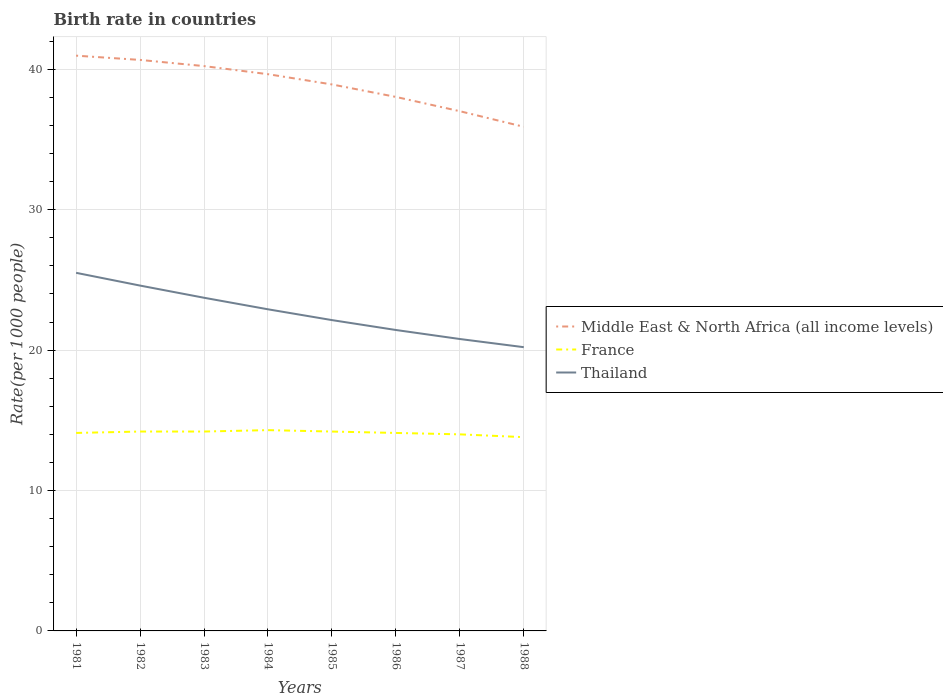How many different coloured lines are there?
Offer a very short reply. 3. Is the number of lines equal to the number of legend labels?
Provide a succinct answer. Yes. Across all years, what is the maximum birth rate in Middle East & North Africa (all income levels)?
Offer a very short reply. 35.9. In which year was the birth rate in Middle East & North Africa (all income levels) maximum?
Give a very brief answer. 1988. What is the total birth rate in Thailand in the graph?
Provide a short and direct response. 3.52. What is the difference between the highest and the second highest birth rate in Thailand?
Offer a terse response. 5.3. How many lines are there?
Your response must be concise. 3. What is the title of the graph?
Your response must be concise. Birth rate in countries. Does "China" appear as one of the legend labels in the graph?
Give a very brief answer. No. What is the label or title of the X-axis?
Your answer should be compact. Years. What is the label or title of the Y-axis?
Ensure brevity in your answer.  Rate(per 1000 people). What is the Rate(per 1000 people) in Middle East & North Africa (all income levels) in 1981?
Give a very brief answer. 40.97. What is the Rate(per 1000 people) in France in 1981?
Your response must be concise. 14.1. What is the Rate(per 1000 people) in Thailand in 1981?
Give a very brief answer. 25.5. What is the Rate(per 1000 people) in Middle East & North Africa (all income levels) in 1982?
Your answer should be compact. 40.67. What is the Rate(per 1000 people) of Thailand in 1982?
Your response must be concise. 24.59. What is the Rate(per 1000 people) of Middle East & North Africa (all income levels) in 1983?
Your answer should be very brief. 40.23. What is the Rate(per 1000 people) of France in 1983?
Your answer should be compact. 14.2. What is the Rate(per 1000 people) in Thailand in 1983?
Give a very brief answer. 23.73. What is the Rate(per 1000 people) of Middle East & North Africa (all income levels) in 1984?
Offer a very short reply. 39.65. What is the Rate(per 1000 people) in France in 1984?
Provide a succinct answer. 14.3. What is the Rate(per 1000 people) of Thailand in 1984?
Your answer should be compact. 22.91. What is the Rate(per 1000 people) of Middle East & North Africa (all income levels) in 1985?
Give a very brief answer. 38.92. What is the Rate(per 1000 people) in Thailand in 1985?
Provide a succinct answer. 22.14. What is the Rate(per 1000 people) in Middle East & North Africa (all income levels) in 1986?
Your answer should be compact. 38.03. What is the Rate(per 1000 people) in France in 1986?
Your answer should be compact. 14.1. What is the Rate(per 1000 people) of Thailand in 1986?
Offer a very short reply. 21.43. What is the Rate(per 1000 people) in Middle East & North Africa (all income levels) in 1987?
Provide a short and direct response. 37.01. What is the Rate(per 1000 people) of France in 1987?
Make the answer very short. 14. What is the Rate(per 1000 people) of Thailand in 1987?
Your response must be concise. 20.79. What is the Rate(per 1000 people) in Middle East & North Africa (all income levels) in 1988?
Provide a short and direct response. 35.9. What is the Rate(per 1000 people) in France in 1988?
Offer a very short reply. 13.8. What is the Rate(per 1000 people) in Thailand in 1988?
Offer a terse response. 20.21. Across all years, what is the maximum Rate(per 1000 people) of Middle East & North Africa (all income levels)?
Your answer should be very brief. 40.97. Across all years, what is the maximum Rate(per 1000 people) of France?
Offer a very short reply. 14.3. Across all years, what is the maximum Rate(per 1000 people) in Thailand?
Your answer should be very brief. 25.5. Across all years, what is the minimum Rate(per 1000 people) in Middle East & North Africa (all income levels)?
Give a very brief answer. 35.9. Across all years, what is the minimum Rate(per 1000 people) in Thailand?
Keep it short and to the point. 20.21. What is the total Rate(per 1000 people) of Middle East & North Africa (all income levels) in the graph?
Make the answer very short. 311.39. What is the total Rate(per 1000 people) in France in the graph?
Keep it short and to the point. 112.9. What is the total Rate(per 1000 people) in Thailand in the graph?
Your response must be concise. 181.3. What is the difference between the Rate(per 1000 people) in Middle East & North Africa (all income levels) in 1981 and that in 1982?
Provide a short and direct response. 0.3. What is the difference between the Rate(per 1000 people) in Thailand in 1981 and that in 1982?
Your answer should be very brief. 0.91. What is the difference between the Rate(per 1000 people) in Middle East & North Africa (all income levels) in 1981 and that in 1983?
Provide a succinct answer. 0.74. What is the difference between the Rate(per 1000 people) of France in 1981 and that in 1983?
Your answer should be compact. -0.1. What is the difference between the Rate(per 1000 people) in Thailand in 1981 and that in 1983?
Your answer should be very brief. 1.78. What is the difference between the Rate(per 1000 people) in Middle East & North Africa (all income levels) in 1981 and that in 1984?
Keep it short and to the point. 1.32. What is the difference between the Rate(per 1000 people) of Thailand in 1981 and that in 1984?
Offer a very short reply. 2.6. What is the difference between the Rate(per 1000 people) of Middle East & North Africa (all income levels) in 1981 and that in 1985?
Your answer should be very brief. 2.05. What is the difference between the Rate(per 1000 people) in Thailand in 1981 and that in 1985?
Your response must be concise. 3.37. What is the difference between the Rate(per 1000 people) of Middle East & North Africa (all income levels) in 1981 and that in 1986?
Provide a short and direct response. 2.94. What is the difference between the Rate(per 1000 people) in France in 1981 and that in 1986?
Offer a very short reply. 0. What is the difference between the Rate(per 1000 people) of Thailand in 1981 and that in 1986?
Offer a terse response. 4.07. What is the difference between the Rate(per 1000 people) of Middle East & North Africa (all income levels) in 1981 and that in 1987?
Provide a short and direct response. 3.96. What is the difference between the Rate(per 1000 people) of Thailand in 1981 and that in 1987?
Your answer should be compact. 4.71. What is the difference between the Rate(per 1000 people) of Middle East & North Africa (all income levels) in 1981 and that in 1988?
Give a very brief answer. 5.07. What is the difference between the Rate(per 1000 people) in France in 1981 and that in 1988?
Make the answer very short. 0.3. What is the difference between the Rate(per 1000 people) of Thailand in 1981 and that in 1988?
Ensure brevity in your answer.  5.3. What is the difference between the Rate(per 1000 people) of Middle East & North Africa (all income levels) in 1982 and that in 1983?
Provide a succinct answer. 0.44. What is the difference between the Rate(per 1000 people) of France in 1982 and that in 1983?
Your response must be concise. 0. What is the difference between the Rate(per 1000 people) in Thailand in 1982 and that in 1983?
Your answer should be very brief. 0.87. What is the difference between the Rate(per 1000 people) in Middle East & North Africa (all income levels) in 1982 and that in 1984?
Make the answer very short. 1.02. What is the difference between the Rate(per 1000 people) in Thailand in 1982 and that in 1984?
Offer a terse response. 1.69. What is the difference between the Rate(per 1000 people) in Middle East & North Africa (all income levels) in 1982 and that in 1985?
Your response must be concise. 1.75. What is the difference between the Rate(per 1000 people) in Thailand in 1982 and that in 1985?
Keep it short and to the point. 2.46. What is the difference between the Rate(per 1000 people) in Middle East & North Africa (all income levels) in 1982 and that in 1986?
Your answer should be compact. 2.63. What is the difference between the Rate(per 1000 people) in France in 1982 and that in 1986?
Offer a terse response. 0.1. What is the difference between the Rate(per 1000 people) of Thailand in 1982 and that in 1986?
Your answer should be very brief. 3.16. What is the difference between the Rate(per 1000 people) of Middle East & North Africa (all income levels) in 1982 and that in 1987?
Make the answer very short. 3.65. What is the difference between the Rate(per 1000 people) in Thailand in 1982 and that in 1987?
Make the answer very short. 3.81. What is the difference between the Rate(per 1000 people) of Middle East & North Africa (all income levels) in 1982 and that in 1988?
Keep it short and to the point. 4.76. What is the difference between the Rate(per 1000 people) of France in 1982 and that in 1988?
Offer a terse response. 0.4. What is the difference between the Rate(per 1000 people) of Thailand in 1982 and that in 1988?
Your answer should be very brief. 4.39. What is the difference between the Rate(per 1000 people) of Middle East & North Africa (all income levels) in 1983 and that in 1984?
Your answer should be compact. 0.58. What is the difference between the Rate(per 1000 people) in Thailand in 1983 and that in 1984?
Your response must be concise. 0.82. What is the difference between the Rate(per 1000 people) in Middle East & North Africa (all income levels) in 1983 and that in 1985?
Your answer should be compact. 1.31. What is the difference between the Rate(per 1000 people) in France in 1983 and that in 1985?
Offer a terse response. 0. What is the difference between the Rate(per 1000 people) in Thailand in 1983 and that in 1985?
Keep it short and to the point. 1.59. What is the difference between the Rate(per 1000 people) in Middle East & North Africa (all income levels) in 1983 and that in 1986?
Your answer should be very brief. 2.2. What is the difference between the Rate(per 1000 people) in Thailand in 1983 and that in 1986?
Give a very brief answer. 2.3. What is the difference between the Rate(per 1000 people) of Middle East & North Africa (all income levels) in 1983 and that in 1987?
Give a very brief answer. 3.21. What is the difference between the Rate(per 1000 people) in Thailand in 1983 and that in 1987?
Your response must be concise. 2.94. What is the difference between the Rate(per 1000 people) of Middle East & North Africa (all income levels) in 1983 and that in 1988?
Provide a succinct answer. 4.32. What is the difference between the Rate(per 1000 people) in France in 1983 and that in 1988?
Offer a very short reply. 0.4. What is the difference between the Rate(per 1000 people) of Thailand in 1983 and that in 1988?
Offer a very short reply. 3.52. What is the difference between the Rate(per 1000 people) of Middle East & North Africa (all income levels) in 1984 and that in 1985?
Your response must be concise. 0.73. What is the difference between the Rate(per 1000 people) in France in 1984 and that in 1985?
Ensure brevity in your answer.  0.1. What is the difference between the Rate(per 1000 people) in Thailand in 1984 and that in 1985?
Offer a very short reply. 0.77. What is the difference between the Rate(per 1000 people) in Middle East & North Africa (all income levels) in 1984 and that in 1986?
Ensure brevity in your answer.  1.62. What is the difference between the Rate(per 1000 people) of Thailand in 1984 and that in 1986?
Offer a terse response. 1.47. What is the difference between the Rate(per 1000 people) in Middle East & North Africa (all income levels) in 1984 and that in 1987?
Offer a terse response. 2.64. What is the difference between the Rate(per 1000 people) of Thailand in 1984 and that in 1987?
Offer a very short reply. 2.12. What is the difference between the Rate(per 1000 people) of Middle East & North Africa (all income levels) in 1984 and that in 1988?
Offer a terse response. 3.75. What is the difference between the Rate(per 1000 people) in Thailand in 1984 and that in 1988?
Provide a succinct answer. 2.7. What is the difference between the Rate(per 1000 people) of Middle East & North Africa (all income levels) in 1985 and that in 1986?
Your answer should be compact. 0.89. What is the difference between the Rate(per 1000 people) in France in 1985 and that in 1986?
Give a very brief answer. 0.1. What is the difference between the Rate(per 1000 people) in Thailand in 1985 and that in 1986?
Your response must be concise. 0.7. What is the difference between the Rate(per 1000 people) of Middle East & North Africa (all income levels) in 1985 and that in 1987?
Your answer should be very brief. 1.91. What is the difference between the Rate(per 1000 people) in France in 1985 and that in 1987?
Your answer should be compact. 0.2. What is the difference between the Rate(per 1000 people) in Thailand in 1985 and that in 1987?
Give a very brief answer. 1.35. What is the difference between the Rate(per 1000 people) of Middle East & North Africa (all income levels) in 1985 and that in 1988?
Your response must be concise. 3.02. What is the difference between the Rate(per 1000 people) in Thailand in 1985 and that in 1988?
Offer a very short reply. 1.93. What is the difference between the Rate(per 1000 people) in Middle East & North Africa (all income levels) in 1986 and that in 1987?
Your response must be concise. 1.02. What is the difference between the Rate(per 1000 people) of Thailand in 1986 and that in 1987?
Your response must be concise. 0.64. What is the difference between the Rate(per 1000 people) in Middle East & North Africa (all income levels) in 1986 and that in 1988?
Ensure brevity in your answer.  2.13. What is the difference between the Rate(per 1000 people) in Thailand in 1986 and that in 1988?
Provide a short and direct response. 1.22. What is the difference between the Rate(per 1000 people) of Middle East & North Africa (all income levels) in 1987 and that in 1988?
Make the answer very short. 1.11. What is the difference between the Rate(per 1000 people) of Thailand in 1987 and that in 1988?
Ensure brevity in your answer.  0.58. What is the difference between the Rate(per 1000 people) of Middle East & North Africa (all income levels) in 1981 and the Rate(per 1000 people) of France in 1982?
Your answer should be compact. 26.77. What is the difference between the Rate(per 1000 people) in Middle East & North Africa (all income levels) in 1981 and the Rate(per 1000 people) in Thailand in 1982?
Keep it short and to the point. 16.38. What is the difference between the Rate(per 1000 people) in France in 1981 and the Rate(per 1000 people) in Thailand in 1982?
Your answer should be very brief. -10.49. What is the difference between the Rate(per 1000 people) in Middle East & North Africa (all income levels) in 1981 and the Rate(per 1000 people) in France in 1983?
Your answer should be compact. 26.77. What is the difference between the Rate(per 1000 people) of Middle East & North Africa (all income levels) in 1981 and the Rate(per 1000 people) of Thailand in 1983?
Give a very brief answer. 17.24. What is the difference between the Rate(per 1000 people) of France in 1981 and the Rate(per 1000 people) of Thailand in 1983?
Keep it short and to the point. -9.63. What is the difference between the Rate(per 1000 people) of Middle East & North Africa (all income levels) in 1981 and the Rate(per 1000 people) of France in 1984?
Your response must be concise. 26.67. What is the difference between the Rate(per 1000 people) in Middle East & North Africa (all income levels) in 1981 and the Rate(per 1000 people) in Thailand in 1984?
Your answer should be very brief. 18.06. What is the difference between the Rate(per 1000 people) of France in 1981 and the Rate(per 1000 people) of Thailand in 1984?
Ensure brevity in your answer.  -8.81. What is the difference between the Rate(per 1000 people) of Middle East & North Africa (all income levels) in 1981 and the Rate(per 1000 people) of France in 1985?
Your response must be concise. 26.77. What is the difference between the Rate(per 1000 people) of Middle East & North Africa (all income levels) in 1981 and the Rate(per 1000 people) of Thailand in 1985?
Keep it short and to the point. 18.83. What is the difference between the Rate(per 1000 people) in France in 1981 and the Rate(per 1000 people) in Thailand in 1985?
Provide a succinct answer. -8.04. What is the difference between the Rate(per 1000 people) of Middle East & North Africa (all income levels) in 1981 and the Rate(per 1000 people) of France in 1986?
Your answer should be compact. 26.87. What is the difference between the Rate(per 1000 people) in Middle East & North Africa (all income levels) in 1981 and the Rate(per 1000 people) in Thailand in 1986?
Provide a succinct answer. 19.54. What is the difference between the Rate(per 1000 people) of France in 1981 and the Rate(per 1000 people) of Thailand in 1986?
Keep it short and to the point. -7.33. What is the difference between the Rate(per 1000 people) in Middle East & North Africa (all income levels) in 1981 and the Rate(per 1000 people) in France in 1987?
Keep it short and to the point. 26.97. What is the difference between the Rate(per 1000 people) in Middle East & North Africa (all income levels) in 1981 and the Rate(per 1000 people) in Thailand in 1987?
Offer a very short reply. 20.18. What is the difference between the Rate(per 1000 people) of France in 1981 and the Rate(per 1000 people) of Thailand in 1987?
Provide a short and direct response. -6.69. What is the difference between the Rate(per 1000 people) of Middle East & North Africa (all income levels) in 1981 and the Rate(per 1000 people) of France in 1988?
Offer a very short reply. 27.17. What is the difference between the Rate(per 1000 people) in Middle East & North Africa (all income levels) in 1981 and the Rate(per 1000 people) in Thailand in 1988?
Offer a terse response. 20.76. What is the difference between the Rate(per 1000 people) in France in 1981 and the Rate(per 1000 people) in Thailand in 1988?
Ensure brevity in your answer.  -6.11. What is the difference between the Rate(per 1000 people) of Middle East & North Africa (all income levels) in 1982 and the Rate(per 1000 people) of France in 1983?
Your answer should be very brief. 26.47. What is the difference between the Rate(per 1000 people) of Middle East & North Africa (all income levels) in 1982 and the Rate(per 1000 people) of Thailand in 1983?
Offer a terse response. 16.94. What is the difference between the Rate(per 1000 people) of France in 1982 and the Rate(per 1000 people) of Thailand in 1983?
Make the answer very short. -9.53. What is the difference between the Rate(per 1000 people) of Middle East & North Africa (all income levels) in 1982 and the Rate(per 1000 people) of France in 1984?
Offer a very short reply. 26.37. What is the difference between the Rate(per 1000 people) in Middle East & North Africa (all income levels) in 1982 and the Rate(per 1000 people) in Thailand in 1984?
Provide a succinct answer. 17.76. What is the difference between the Rate(per 1000 people) of France in 1982 and the Rate(per 1000 people) of Thailand in 1984?
Give a very brief answer. -8.71. What is the difference between the Rate(per 1000 people) in Middle East & North Africa (all income levels) in 1982 and the Rate(per 1000 people) in France in 1985?
Offer a terse response. 26.47. What is the difference between the Rate(per 1000 people) in Middle East & North Africa (all income levels) in 1982 and the Rate(per 1000 people) in Thailand in 1985?
Provide a short and direct response. 18.53. What is the difference between the Rate(per 1000 people) in France in 1982 and the Rate(per 1000 people) in Thailand in 1985?
Your answer should be very brief. -7.94. What is the difference between the Rate(per 1000 people) of Middle East & North Africa (all income levels) in 1982 and the Rate(per 1000 people) of France in 1986?
Ensure brevity in your answer.  26.57. What is the difference between the Rate(per 1000 people) in Middle East & North Africa (all income levels) in 1982 and the Rate(per 1000 people) in Thailand in 1986?
Give a very brief answer. 19.23. What is the difference between the Rate(per 1000 people) of France in 1982 and the Rate(per 1000 people) of Thailand in 1986?
Give a very brief answer. -7.23. What is the difference between the Rate(per 1000 people) of Middle East & North Africa (all income levels) in 1982 and the Rate(per 1000 people) of France in 1987?
Keep it short and to the point. 26.67. What is the difference between the Rate(per 1000 people) of Middle East & North Africa (all income levels) in 1982 and the Rate(per 1000 people) of Thailand in 1987?
Provide a short and direct response. 19.88. What is the difference between the Rate(per 1000 people) of France in 1982 and the Rate(per 1000 people) of Thailand in 1987?
Ensure brevity in your answer.  -6.59. What is the difference between the Rate(per 1000 people) in Middle East & North Africa (all income levels) in 1982 and the Rate(per 1000 people) in France in 1988?
Give a very brief answer. 26.87. What is the difference between the Rate(per 1000 people) of Middle East & North Africa (all income levels) in 1982 and the Rate(per 1000 people) of Thailand in 1988?
Your answer should be compact. 20.46. What is the difference between the Rate(per 1000 people) of France in 1982 and the Rate(per 1000 people) of Thailand in 1988?
Offer a terse response. -6.01. What is the difference between the Rate(per 1000 people) of Middle East & North Africa (all income levels) in 1983 and the Rate(per 1000 people) of France in 1984?
Provide a short and direct response. 25.93. What is the difference between the Rate(per 1000 people) of Middle East & North Africa (all income levels) in 1983 and the Rate(per 1000 people) of Thailand in 1984?
Offer a terse response. 17.32. What is the difference between the Rate(per 1000 people) in France in 1983 and the Rate(per 1000 people) in Thailand in 1984?
Offer a very short reply. -8.71. What is the difference between the Rate(per 1000 people) in Middle East & North Africa (all income levels) in 1983 and the Rate(per 1000 people) in France in 1985?
Give a very brief answer. 26.03. What is the difference between the Rate(per 1000 people) of Middle East & North Africa (all income levels) in 1983 and the Rate(per 1000 people) of Thailand in 1985?
Your answer should be very brief. 18.09. What is the difference between the Rate(per 1000 people) of France in 1983 and the Rate(per 1000 people) of Thailand in 1985?
Give a very brief answer. -7.94. What is the difference between the Rate(per 1000 people) of Middle East & North Africa (all income levels) in 1983 and the Rate(per 1000 people) of France in 1986?
Your response must be concise. 26.13. What is the difference between the Rate(per 1000 people) in Middle East & North Africa (all income levels) in 1983 and the Rate(per 1000 people) in Thailand in 1986?
Your response must be concise. 18.8. What is the difference between the Rate(per 1000 people) of France in 1983 and the Rate(per 1000 people) of Thailand in 1986?
Make the answer very short. -7.23. What is the difference between the Rate(per 1000 people) in Middle East & North Africa (all income levels) in 1983 and the Rate(per 1000 people) in France in 1987?
Provide a short and direct response. 26.23. What is the difference between the Rate(per 1000 people) of Middle East & North Africa (all income levels) in 1983 and the Rate(per 1000 people) of Thailand in 1987?
Provide a succinct answer. 19.44. What is the difference between the Rate(per 1000 people) in France in 1983 and the Rate(per 1000 people) in Thailand in 1987?
Provide a succinct answer. -6.59. What is the difference between the Rate(per 1000 people) of Middle East & North Africa (all income levels) in 1983 and the Rate(per 1000 people) of France in 1988?
Offer a very short reply. 26.43. What is the difference between the Rate(per 1000 people) in Middle East & North Africa (all income levels) in 1983 and the Rate(per 1000 people) in Thailand in 1988?
Offer a terse response. 20.02. What is the difference between the Rate(per 1000 people) in France in 1983 and the Rate(per 1000 people) in Thailand in 1988?
Your response must be concise. -6.01. What is the difference between the Rate(per 1000 people) of Middle East & North Africa (all income levels) in 1984 and the Rate(per 1000 people) of France in 1985?
Make the answer very short. 25.45. What is the difference between the Rate(per 1000 people) of Middle East & North Africa (all income levels) in 1984 and the Rate(per 1000 people) of Thailand in 1985?
Offer a terse response. 17.51. What is the difference between the Rate(per 1000 people) in France in 1984 and the Rate(per 1000 people) in Thailand in 1985?
Offer a very short reply. -7.84. What is the difference between the Rate(per 1000 people) of Middle East & North Africa (all income levels) in 1984 and the Rate(per 1000 people) of France in 1986?
Offer a terse response. 25.55. What is the difference between the Rate(per 1000 people) of Middle East & North Africa (all income levels) in 1984 and the Rate(per 1000 people) of Thailand in 1986?
Offer a terse response. 18.22. What is the difference between the Rate(per 1000 people) of France in 1984 and the Rate(per 1000 people) of Thailand in 1986?
Keep it short and to the point. -7.13. What is the difference between the Rate(per 1000 people) in Middle East & North Africa (all income levels) in 1984 and the Rate(per 1000 people) in France in 1987?
Provide a succinct answer. 25.65. What is the difference between the Rate(per 1000 people) in Middle East & North Africa (all income levels) in 1984 and the Rate(per 1000 people) in Thailand in 1987?
Keep it short and to the point. 18.86. What is the difference between the Rate(per 1000 people) of France in 1984 and the Rate(per 1000 people) of Thailand in 1987?
Your answer should be very brief. -6.49. What is the difference between the Rate(per 1000 people) of Middle East & North Africa (all income levels) in 1984 and the Rate(per 1000 people) of France in 1988?
Provide a succinct answer. 25.85. What is the difference between the Rate(per 1000 people) of Middle East & North Africa (all income levels) in 1984 and the Rate(per 1000 people) of Thailand in 1988?
Offer a terse response. 19.44. What is the difference between the Rate(per 1000 people) in France in 1984 and the Rate(per 1000 people) in Thailand in 1988?
Give a very brief answer. -5.91. What is the difference between the Rate(per 1000 people) in Middle East & North Africa (all income levels) in 1985 and the Rate(per 1000 people) in France in 1986?
Your answer should be very brief. 24.82. What is the difference between the Rate(per 1000 people) in Middle East & North Africa (all income levels) in 1985 and the Rate(per 1000 people) in Thailand in 1986?
Your answer should be very brief. 17.49. What is the difference between the Rate(per 1000 people) in France in 1985 and the Rate(per 1000 people) in Thailand in 1986?
Provide a short and direct response. -7.23. What is the difference between the Rate(per 1000 people) of Middle East & North Africa (all income levels) in 1985 and the Rate(per 1000 people) of France in 1987?
Provide a succinct answer. 24.92. What is the difference between the Rate(per 1000 people) in Middle East & North Africa (all income levels) in 1985 and the Rate(per 1000 people) in Thailand in 1987?
Ensure brevity in your answer.  18.13. What is the difference between the Rate(per 1000 people) of France in 1985 and the Rate(per 1000 people) of Thailand in 1987?
Your answer should be compact. -6.59. What is the difference between the Rate(per 1000 people) in Middle East & North Africa (all income levels) in 1985 and the Rate(per 1000 people) in France in 1988?
Make the answer very short. 25.12. What is the difference between the Rate(per 1000 people) in Middle East & North Africa (all income levels) in 1985 and the Rate(per 1000 people) in Thailand in 1988?
Offer a very short reply. 18.71. What is the difference between the Rate(per 1000 people) of France in 1985 and the Rate(per 1000 people) of Thailand in 1988?
Your response must be concise. -6.01. What is the difference between the Rate(per 1000 people) of Middle East & North Africa (all income levels) in 1986 and the Rate(per 1000 people) of France in 1987?
Your answer should be compact. 24.03. What is the difference between the Rate(per 1000 people) of Middle East & North Africa (all income levels) in 1986 and the Rate(per 1000 people) of Thailand in 1987?
Provide a succinct answer. 17.24. What is the difference between the Rate(per 1000 people) in France in 1986 and the Rate(per 1000 people) in Thailand in 1987?
Keep it short and to the point. -6.69. What is the difference between the Rate(per 1000 people) of Middle East & North Africa (all income levels) in 1986 and the Rate(per 1000 people) of France in 1988?
Provide a short and direct response. 24.23. What is the difference between the Rate(per 1000 people) in Middle East & North Africa (all income levels) in 1986 and the Rate(per 1000 people) in Thailand in 1988?
Your answer should be compact. 17.82. What is the difference between the Rate(per 1000 people) in France in 1986 and the Rate(per 1000 people) in Thailand in 1988?
Your response must be concise. -6.11. What is the difference between the Rate(per 1000 people) in Middle East & North Africa (all income levels) in 1987 and the Rate(per 1000 people) in France in 1988?
Your answer should be very brief. 23.21. What is the difference between the Rate(per 1000 people) of Middle East & North Africa (all income levels) in 1987 and the Rate(per 1000 people) of Thailand in 1988?
Make the answer very short. 16.81. What is the difference between the Rate(per 1000 people) of France in 1987 and the Rate(per 1000 people) of Thailand in 1988?
Provide a short and direct response. -6.21. What is the average Rate(per 1000 people) of Middle East & North Africa (all income levels) per year?
Keep it short and to the point. 38.92. What is the average Rate(per 1000 people) of France per year?
Give a very brief answer. 14.11. What is the average Rate(per 1000 people) in Thailand per year?
Make the answer very short. 22.66. In the year 1981, what is the difference between the Rate(per 1000 people) in Middle East & North Africa (all income levels) and Rate(per 1000 people) in France?
Your answer should be very brief. 26.87. In the year 1981, what is the difference between the Rate(per 1000 people) of Middle East & North Africa (all income levels) and Rate(per 1000 people) of Thailand?
Your answer should be compact. 15.47. In the year 1981, what is the difference between the Rate(per 1000 people) of France and Rate(per 1000 people) of Thailand?
Ensure brevity in your answer.  -11.4. In the year 1982, what is the difference between the Rate(per 1000 people) of Middle East & North Africa (all income levels) and Rate(per 1000 people) of France?
Provide a short and direct response. 26.47. In the year 1982, what is the difference between the Rate(per 1000 people) in Middle East & North Africa (all income levels) and Rate(per 1000 people) in Thailand?
Keep it short and to the point. 16.07. In the year 1982, what is the difference between the Rate(per 1000 people) of France and Rate(per 1000 people) of Thailand?
Provide a succinct answer. -10.39. In the year 1983, what is the difference between the Rate(per 1000 people) in Middle East & North Africa (all income levels) and Rate(per 1000 people) in France?
Offer a terse response. 26.03. In the year 1983, what is the difference between the Rate(per 1000 people) of Middle East & North Africa (all income levels) and Rate(per 1000 people) of Thailand?
Ensure brevity in your answer.  16.5. In the year 1983, what is the difference between the Rate(per 1000 people) in France and Rate(per 1000 people) in Thailand?
Provide a short and direct response. -9.53. In the year 1984, what is the difference between the Rate(per 1000 people) in Middle East & North Africa (all income levels) and Rate(per 1000 people) in France?
Give a very brief answer. 25.35. In the year 1984, what is the difference between the Rate(per 1000 people) in Middle East & North Africa (all income levels) and Rate(per 1000 people) in Thailand?
Your answer should be very brief. 16.74. In the year 1984, what is the difference between the Rate(per 1000 people) of France and Rate(per 1000 people) of Thailand?
Give a very brief answer. -8.61. In the year 1985, what is the difference between the Rate(per 1000 people) of Middle East & North Africa (all income levels) and Rate(per 1000 people) of France?
Your response must be concise. 24.72. In the year 1985, what is the difference between the Rate(per 1000 people) of Middle East & North Africa (all income levels) and Rate(per 1000 people) of Thailand?
Offer a very short reply. 16.78. In the year 1985, what is the difference between the Rate(per 1000 people) in France and Rate(per 1000 people) in Thailand?
Make the answer very short. -7.94. In the year 1986, what is the difference between the Rate(per 1000 people) in Middle East & North Africa (all income levels) and Rate(per 1000 people) in France?
Provide a succinct answer. 23.93. In the year 1986, what is the difference between the Rate(per 1000 people) in France and Rate(per 1000 people) in Thailand?
Your answer should be compact. -7.33. In the year 1987, what is the difference between the Rate(per 1000 people) in Middle East & North Africa (all income levels) and Rate(per 1000 people) in France?
Offer a very short reply. 23.01. In the year 1987, what is the difference between the Rate(per 1000 people) of Middle East & North Africa (all income levels) and Rate(per 1000 people) of Thailand?
Offer a very short reply. 16.22. In the year 1987, what is the difference between the Rate(per 1000 people) in France and Rate(per 1000 people) in Thailand?
Keep it short and to the point. -6.79. In the year 1988, what is the difference between the Rate(per 1000 people) in Middle East & North Africa (all income levels) and Rate(per 1000 people) in France?
Ensure brevity in your answer.  22.1. In the year 1988, what is the difference between the Rate(per 1000 people) in Middle East & North Africa (all income levels) and Rate(per 1000 people) in Thailand?
Provide a succinct answer. 15.7. In the year 1988, what is the difference between the Rate(per 1000 people) of France and Rate(per 1000 people) of Thailand?
Make the answer very short. -6.41. What is the ratio of the Rate(per 1000 people) in Middle East & North Africa (all income levels) in 1981 to that in 1982?
Make the answer very short. 1.01. What is the ratio of the Rate(per 1000 people) in France in 1981 to that in 1982?
Keep it short and to the point. 0.99. What is the ratio of the Rate(per 1000 people) in Thailand in 1981 to that in 1982?
Provide a succinct answer. 1.04. What is the ratio of the Rate(per 1000 people) of Middle East & North Africa (all income levels) in 1981 to that in 1983?
Provide a succinct answer. 1.02. What is the ratio of the Rate(per 1000 people) of France in 1981 to that in 1983?
Your answer should be compact. 0.99. What is the ratio of the Rate(per 1000 people) of Thailand in 1981 to that in 1983?
Your answer should be very brief. 1.07. What is the ratio of the Rate(per 1000 people) in Middle East & North Africa (all income levels) in 1981 to that in 1984?
Ensure brevity in your answer.  1.03. What is the ratio of the Rate(per 1000 people) in France in 1981 to that in 1984?
Make the answer very short. 0.99. What is the ratio of the Rate(per 1000 people) in Thailand in 1981 to that in 1984?
Provide a short and direct response. 1.11. What is the ratio of the Rate(per 1000 people) in Middle East & North Africa (all income levels) in 1981 to that in 1985?
Give a very brief answer. 1.05. What is the ratio of the Rate(per 1000 people) in Thailand in 1981 to that in 1985?
Provide a short and direct response. 1.15. What is the ratio of the Rate(per 1000 people) in Middle East & North Africa (all income levels) in 1981 to that in 1986?
Offer a terse response. 1.08. What is the ratio of the Rate(per 1000 people) in Thailand in 1981 to that in 1986?
Your answer should be very brief. 1.19. What is the ratio of the Rate(per 1000 people) in Middle East & North Africa (all income levels) in 1981 to that in 1987?
Your response must be concise. 1.11. What is the ratio of the Rate(per 1000 people) in France in 1981 to that in 1987?
Your answer should be compact. 1.01. What is the ratio of the Rate(per 1000 people) in Thailand in 1981 to that in 1987?
Give a very brief answer. 1.23. What is the ratio of the Rate(per 1000 people) of Middle East & North Africa (all income levels) in 1981 to that in 1988?
Provide a succinct answer. 1.14. What is the ratio of the Rate(per 1000 people) of France in 1981 to that in 1988?
Make the answer very short. 1.02. What is the ratio of the Rate(per 1000 people) in Thailand in 1981 to that in 1988?
Keep it short and to the point. 1.26. What is the ratio of the Rate(per 1000 people) of Middle East & North Africa (all income levels) in 1982 to that in 1983?
Your answer should be compact. 1.01. What is the ratio of the Rate(per 1000 people) of France in 1982 to that in 1983?
Make the answer very short. 1. What is the ratio of the Rate(per 1000 people) in Thailand in 1982 to that in 1983?
Make the answer very short. 1.04. What is the ratio of the Rate(per 1000 people) in Middle East & North Africa (all income levels) in 1982 to that in 1984?
Make the answer very short. 1.03. What is the ratio of the Rate(per 1000 people) of France in 1982 to that in 1984?
Ensure brevity in your answer.  0.99. What is the ratio of the Rate(per 1000 people) in Thailand in 1982 to that in 1984?
Provide a short and direct response. 1.07. What is the ratio of the Rate(per 1000 people) in Middle East & North Africa (all income levels) in 1982 to that in 1985?
Provide a succinct answer. 1.04. What is the ratio of the Rate(per 1000 people) of France in 1982 to that in 1985?
Ensure brevity in your answer.  1. What is the ratio of the Rate(per 1000 people) of Thailand in 1982 to that in 1985?
Give a very brief answer. 1.11. What is the ratio of the Rate(per 1000 people) in Middle East & North Africa (all income levels) in 1982 to that in 1986?
Offer a terse response. 1.07. What is the ratio of the Rate(per 1000 people) of France in 1982 to that in 1986?
Provide a succinct answer. 1.01. What is the ratio of the Rate(per 1000 people) of Thailand in 1982 to that in 1986?
Provide a succinct answer. 1.15. What is the ratio of the Rate(per 1000 people) of Middle East & North Africa (all income levels) in 1982 to that in 1987?
Keep it short and to the point. 1.1. What is the ratio of the Rate(per 1000 people) in France in 1982 to that in 1987?
Give a very brief answer. 1.01. What is the ratio of the Rate(per 1000 people) of Thailand in 1982 to that in 1987?
Offer a very short reply. 1.18. What is the ratio of the Rate(per 1000 people) of Middle East & North Africa (all income levels) in 1982 to that in 1988?
Ensure brevity in your answer.  1.13. What is the ratio of the Rate(per 1000 people) of France in 1982 to that in 1988?
Ensure brevity in your answer.  1.03. What is the ratio of the Rate(per 1000 people) of Thailand in 1982 to that in 1988?
Provide a succinct answer. 1.22. What is the ratio of the Rate(per 1000 people) of Middle East & North Africa (all income levels) in 1983 to that in 1984?
Provide a succinct answer. 1.01. What is the ratio of the Rate(per 1000 people) of France in 1983 to that in 1984?
Your answer should be very brief. 0.99. What is the ratio of the Rate(per 1000 people) of Thailand in 1983 to that in 1984?
Provide a succinct answer. 1.04. What is the ratio of the Rate(per 1000 people) of Middle East & North Africa (all income levels) in 1983 to that in 1985?
Provide a short and direct response. 1.03. What is the ratio of the Rate(per 1000 people) in Thailand in 1983 to that in 1985?
Give a very brief answer. 1.07. What is the ratio of the Rate(per 1000 people) in Middle East & North Africa (all income levels) in 1983 to that in 1986?
Provide a succinct answer. 1.06. What is the ratio of the Rate(per 1000 people) of France in 1983 to that in 1986?
Provide a succinct answer. 1.01. What is the ratio of the Rate(per 1000 people) in Thailand in 1983 to that in 1986?
Make the answer very short. 1.11. What is the ratio of the Rate(per 1000 people) of Middle East & North Africa (all income levels) in 1983 to that in 1987?
Offer a very short reply. 1.09. What is the ratio of the Rate(per 1000 people) in France in 1983 to that in 1987?
Offer a terse response. 1.01. What is the ratio of the Rate(per 1000 people) in Thailand in 1983 to that in 1987?
Your answer should be compact. 1.14. What is the ratio of the Rate(per 1000 people) in Middle East & North Africa (all income levels) in 1983 to that in 1988?
Offer a very short reply. 1.12. What is the ratio of the Rate(per 1000 people) in Thailand in 1983 to that in 1988?
Ensure brevity in your answer.  1.17. What is the ratio of the Rate(per 1000 people) of Middle East & North Africa (all income levels) in 1984 to that in 1985?
Your answer should be very brief. 1.02. What is the ratio of the Rate(per 1000 people) in France in 1984 to that in 1985?
Your answer should be compact. 1.01. What is the ratio of the Rate(per 1000 people) in Thailand in 1984 to that in 1985?
Your answer should be very brief. 1.03. What is the ratio of the Rate(per 1000 people) in Middle East & North Africa (all income levels) in 1984 to that in 1986?
Your answer should be very brief. 1.04. What is the ratio of the Rate(per 1000 people) of France in 1984 to that in 1986?
Your answer should be compact. 1.01. What is the ratio of the Rate(per 1000 people) of Thailand in 1984 to that in 1986?
Give a very brief answer. 1.07. What is the ratio of the Rate(per 1000 people) in Middle East & North Africa (all income levels) in 1984 to that in 1987?
Ensure brevity in your answer.  1.07. What is the ratio of the Rate(per 1000 people) of France in 1984 to that in 1987?
Your answer should be compact. 1.02. What is the ratio of the Rate(per 1000 people) of Thailand in 1984 to that in 1987?
Ensure brevity in your answer.  1.1. What is the ratio of the Rate(per 1000 people) of Middle East & North Africa (all income levels) in 1984 to that in 1988?
Give a very brief answer. 1.1. What is the ratio of the Rate(per 1000 people) of France in 1984 to that in 1988?
Give a very brief answer. 1.04. What is the ratio of the Rate(per 1000 people) in Thailand in 1984 to that in 1988?
Give a very brief answer. 1.13. What is the ratio of the Rate(per 1000 people) of Middle East & North Africa (all income levels) in 1985 to that in 1986?
Your answer should be very brief. 1.02. What is the ratio of the Rate(per 1000 people) of France in 1985 to that in 1986?
Offer a terse response. 1.01. What is the ratio of the Rate(per 1000 people) in Thailand in 1985 to that in 1986?
Your response must be concise. 1.03. What is the ratio of the Rate(per 1000 people) of Middle East & North Africa (all income levels) in 1985 to that in 1987?
Your answer should be compact. 1.05. What is the ratio of the Rate(per 1000 people) of France in 1985 to that in 1987?
Make the answer very short. 1.01. What is the ratio of the Rate(per 1000 people) in Thailand in 1985 to that in 1987?
Make the answer very short. 1.06. What is the ratio of the Rate(per 1000 people) in Middle East & North Africa (all income levels) in 1985 to that in 1988?
Your response must be concise. 1.08. What is the ratio of the Rate(per 1000 people) of France in 1985 to that in 1988?
Provide a succinct answer. 1.03. What is the ratio of the Rate(per 1000 people) in Thailand in 1985 to that in 1988?
Provide a succinct answer. 1.1. What is the ratio of the Rate(per 1000 people) in Middle East & North Africa (all income levels) in 1986 to that in 1987?
Give a very brief answer. 1.03. What is the ratio of the Rate(per 1000 people) in France in 1986 to that in 1987?
Your answer should be compact. 1.01. What is the ratio of the Rate(per 1000 people) of Thailand in 1986 to that in 1987?
Offer a very short reply. 1.03. What is the ratio of the Rate(per 1000 people) of Middle East & North Africa (all income levels) in 1986 to that in 1988?
Make the answer very short. 1.06. What is the ratio of the Rate(per 1000 people) of France in 1986 to that in 1988?
Offer a very short reply. 1.02. What is the ratio of the Rate(per 1000 people) in Thailand in 1986 to that in 1988?
Your response must be concise. 1.06. What is the ratio of the Rate(per 1000 people) of Middle East & North Africa (all income levels) in 1987 to that in 1988?
Your answer should be compact. 1.03. What is the ratio of the Rate(per 1000 people) in France in 1987 to that in 1988?
Offer a very short reply. 1.01. What is the ratio of the Rate(per 1000 people) in Thailand in 1987 to that in 1988?
Give a very brief answer. 1.03. What is the difference between the highest and the second highest Rate(per 1000 people) in Middle East & North Africa (all income levels)?
Give a very brief answer. 0.3. What is the difference between the highest and the second highest Rate(per 1000 people) of France?
Your answer should be compact. 0.1. What is the difference between the highest and the second highest Rate(per 1000 people) of Thailand?
Give a very brief answer. 0.91. What is the difference between the highest and the lowest Rate(per 1000 people) in Middle East & North Africa (all income levels)?
Give a very brief answer. 5.07. What is the difference between the highest and the lowest Rate(per 1000 people) of France?
Give a very brief answer. 0.5. What is the difference between the highest and the lowest Rate(per 1000 people) of Thailand?
Give a very brief answer. 5.3. 